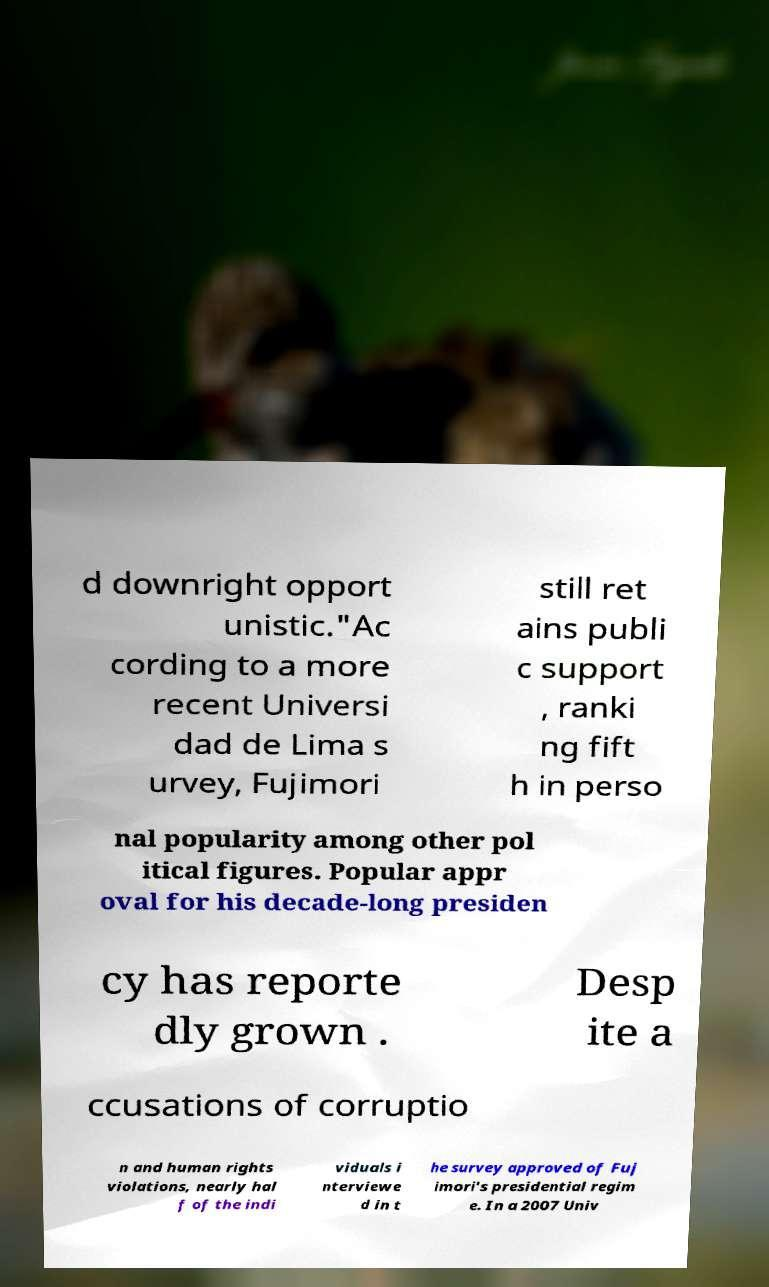Please identify and transcribe the text found in this image. d downright opport unistic."Ac cording to a more recent Universi dad de Lima s urvey, Fujimori still ret ains publi c support , ranki ng fift h in perso nal popularity among other pol itical figures. Popular appr oval for his decade-long presiden cy has reporte dly grown . Desp ite a ccusations of corruptio n and human rights violations, nearly hal f of the indi viduals i nterviewe d in t he survey approved of Fuj imori's presidential regim e. In a 2007 Univ 